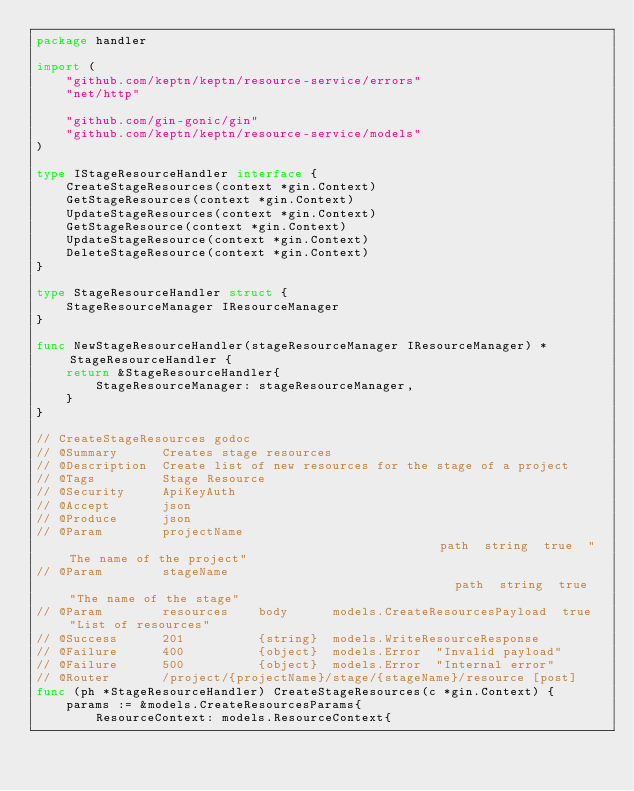<code> <loc_0><loc_0><loc_500><loc_500><_Go_>package handler

import (
	"github.com/keptn/keptn/resource-service/errors"
	"net/http"

	"github.com/gin-gonic/gin"
	"github.com/keptn/keptn/resource-service/models"
)

type IStageResourceHandler interface {
	CreateStageResources(context *gin.Context)
	GetStageResources(context *gin.Context)
	UpdateStageResources(context *gin.Context)
	GetStageResource(context *gin.Context)
	UpdateStageResource(context *gin.Context)
	DeleteStageResource(context *gin.Context)
}

type StageResourceHandler struct {
	StageResourceManager IResourceManager
}

func NewStageResourceHandler(stageResourceManager IResourceManager) *StageResourceHandler {
	return &StageResourceHandler{
		StageResourceManager: stageResourceManager,
	}
}

// CreateStageResources godoc
// @Summary      Creates stage resources
// @Description  Create list of new resources for the stage of a project
// @Tags         Stage Resource
// @Security     ApiKeyAuth
// @Accept       json
// @Produce      json
// @Param        projectName                                                   path  string  true  "The name of the project"
// @Param        stageName                                                     path  string  true  "The name of the stage"
// @Param        resources    body      models.CreateResourcesPayload  true  "List of resources"
// @Success      201          {string}  models.WriteResourceResponse
// @Failure      400          {object}  models.Error  "Invalid payload"
// @Failure      500          {object}  models.Error  "Internal error"
// @Router       /project/{projectName}/stage/{stageName}/resource [post]
func (ph *StageResourceHandler) CreateStageResources(c *gin.Context) {
	params := &models.CreateResourcesParams{
		ResourceContext: models.ResourceContext{</code> 